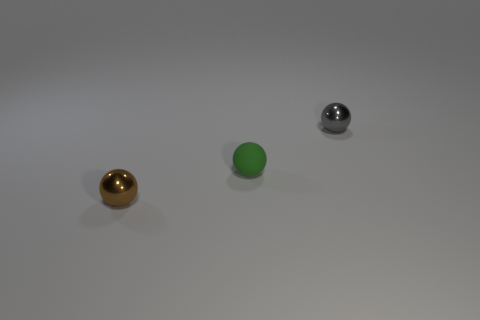Do the gray ball and the brown object have the same material?
Your answer should be very brief. Yes. How many spheres are tiny gray metallic things or tiny rubber things?
Your answer should be very brief. 2. What is the color of the tiny metal ball in front of the small gray shiny sphere?
Give a very brief answer. Brown. What number of matte things are either tiny brown objects or tiny gray things?
Keep it short and to the point. 0. There is a green object left of the tiny shiny sphere that is behind the brown thing; what is its material?
Make the answer very short. Rubber. What is the color of the rubber object?
Your response must be concise. Green. Is there a tiny gray object behind the small brown metal ball that is to the left of the small gray thing?
Your answer should be compact. Yes. What material is the tiny brown object?
Keep it short and to the point. Metal. Does the brown ball that is in front of the gray object have the same material as the green ball that is on the right side of the brown metallic thing?
Keep it short and to the point. No. What is the color of the other metal object that is the same shape as the small brown metallic object?
Provide a short and direct response. Gray. 